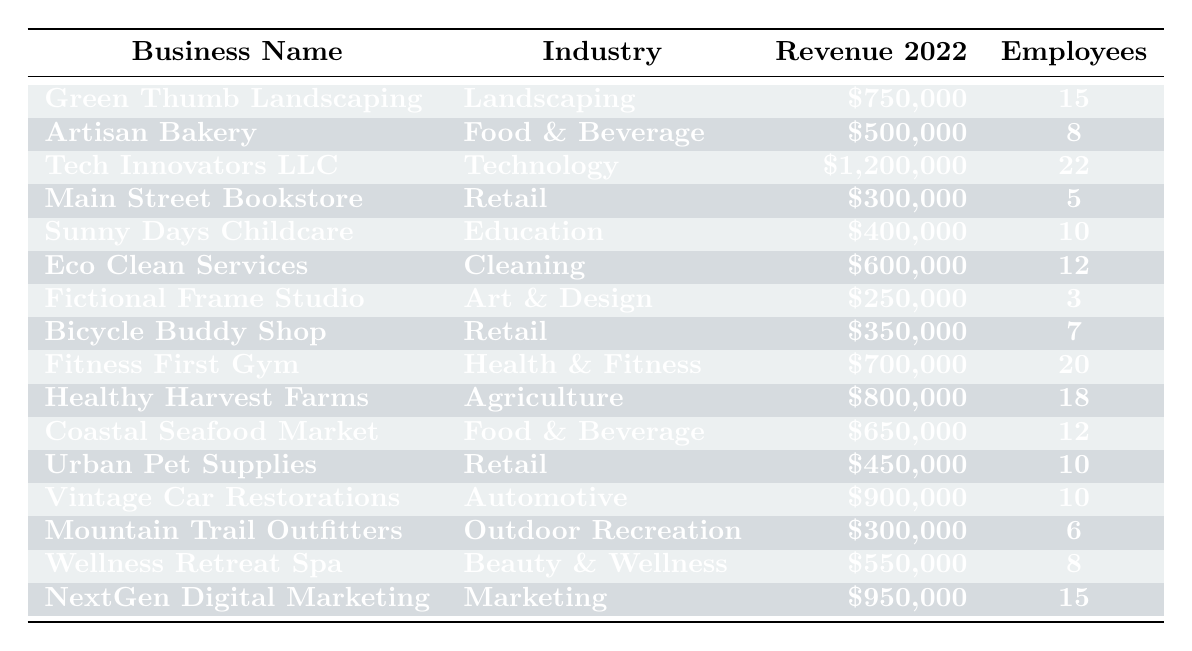What is the revenue of Tech Innovators LLC? The revenue for Tech Innovators LLC is listed in the table under the "Revenue 2022" column, which shows a value of $1,200,000.
Answer: $1,200,000 How many employees does Eco Clean Services have? By checking the "Employees" column for Eco Clean Services, the value listed is 12.
Answer: 12 Which business has the highest revenue? The table shows revenues for all businesses, and Tech Innovators LLC has the highest revenue at $1,200,000.
Answer: Tech Innovators LLC What is the total revenue generated by the Food & Beverage industry? Adding the revenues of both Artisan Bakery ($500,000) and Coastal Seafood Market ($650,000) gives a total of $500,000 + $650,000 = $1,150,000.
Answer: $1,150,000 How many employees work in the Retail industry? The Retail industry includes Main Street Bookstore (5 employees), Bicycle Buddy Shop (7 employees), and Urban Pet Supplies (10 employees). So, total employees = 5 + 7 + 10 = 22.
Answer: 22 Is the revenue of Healthy Harvest Farms greater than $700,000? Healthy Harvest Farms has a revenue of $800,000, which is indeed greater than $700,000.
Answer: Yes What is the average number of employees across all businesses? To find the average, sum all employee counts (15 + 8 + 22 + 5 + 10 + 12 + 3 + 7 + 20 + 18 + 12 + 10 + 6 + 8 + 15) =  15 + 8 + 22 + 5 + 10 + 12 + 3 + 7 + 20 + 18 + 12 + 10 + 6 + 8 + 15 =  8 + 22 + 20 + 18 + 15 = 185; then divide by the total number of businesses (15), resulting in the average of 185 / 15 ≈ 12.33, which rounds to about 12 given the context.
Answer: 12 Which business has the lowest employee count? The employee counts from the table show that Fictional Frame Studio has the lowest with 3 employees.
Answer: Fictional Frame Studio Can we say that the Technology industry employs more than 20 people? Tech Innovators LLC employs 22 people, confirming that the Technology industry does employ more than 20 people.
Answer: Yes What percentage of total revenue does Fitness First Gym contribute? The total revenue across all businesses is $750,000 + $500,000 + $1,200,000 + $300,000 + $400,000 + $600,000 + $250,000 + $350,000 + $700,000 + $800,000 + $650,000 + $450,000 + $900,000 + $300,000 + $550,000 + $950,000 = $8,250,000. Fitness First Gym’s revenue of $700,000 represents ($700,000 / $8,250,000) * 100 ≈ 8.48%.
Answer: 8.48% 